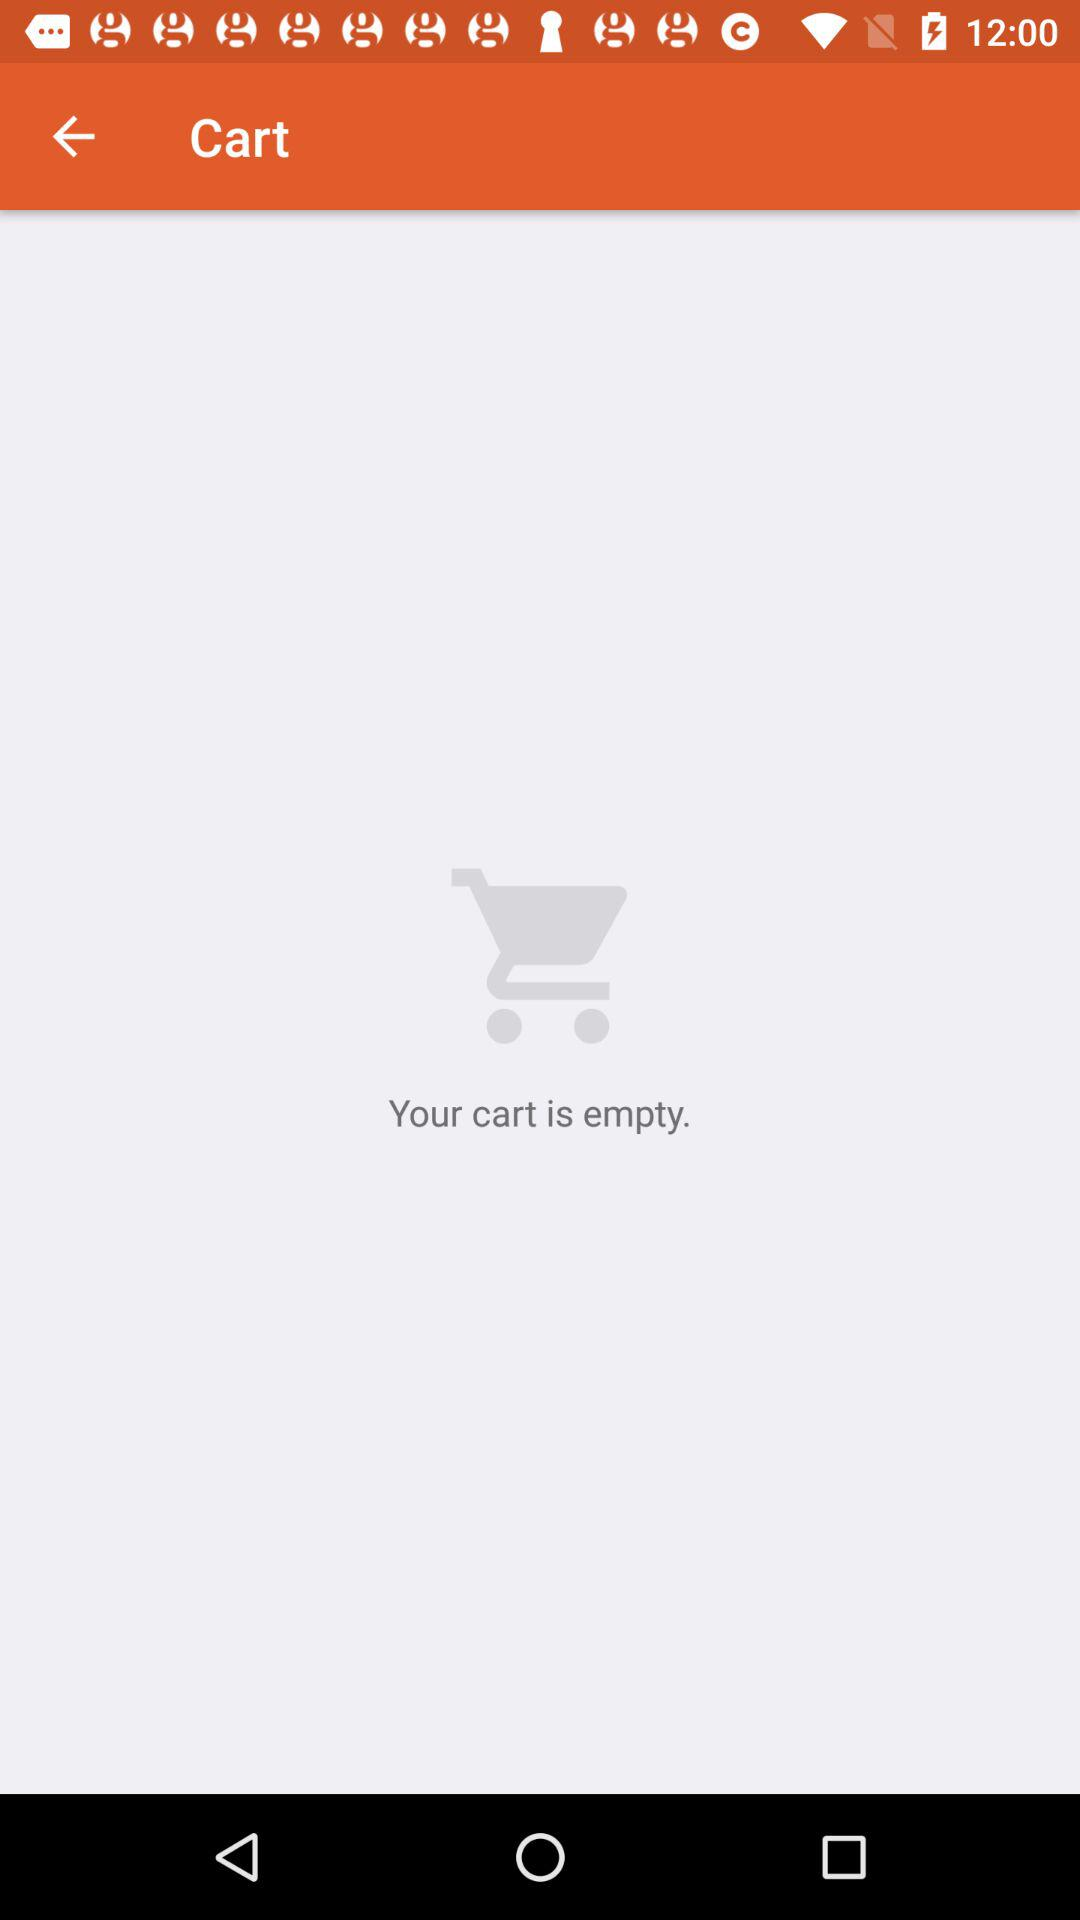How many items are in the shopping cart?
Answer the question using a single word or phrase. 0 